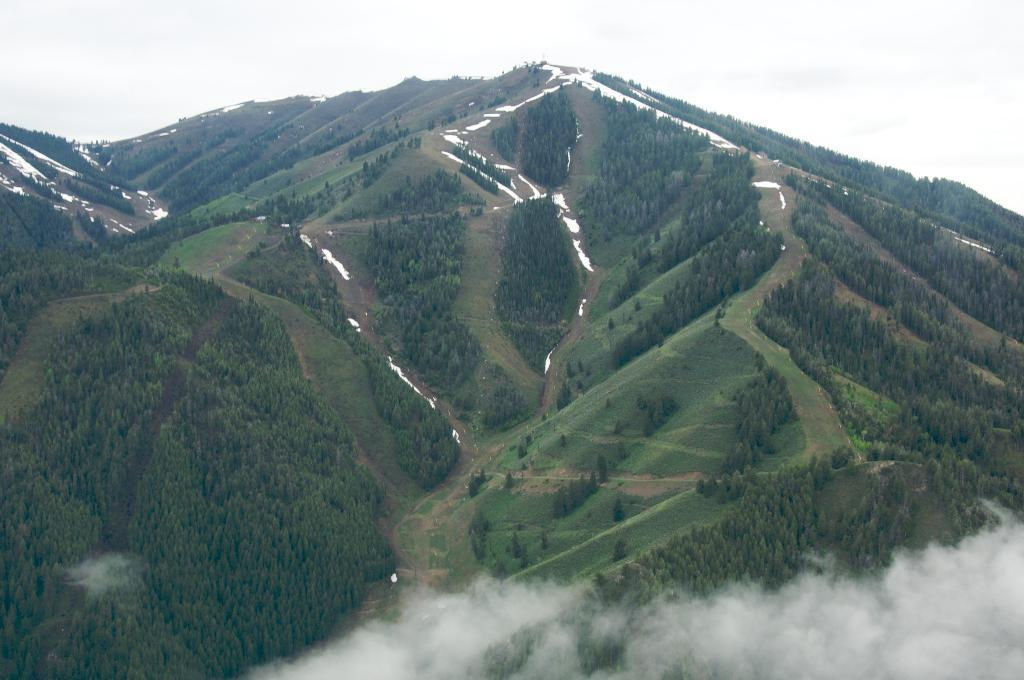What type of natural feature is in the middle of the image? There is a mountain in the middle of the image. What is located on the mountain in the image? There are trees on the mountain in the image. What is visible at the top of the image? The sky is visible at the top of the image. How many cars are parked on the mountain in the image? There are no cars present in the image; it features a mountain with trees. What type of hairstyle does the tree on the mountain have? There is no reference to hair or a hairstyle in the image, as it features a mountain with trees. 